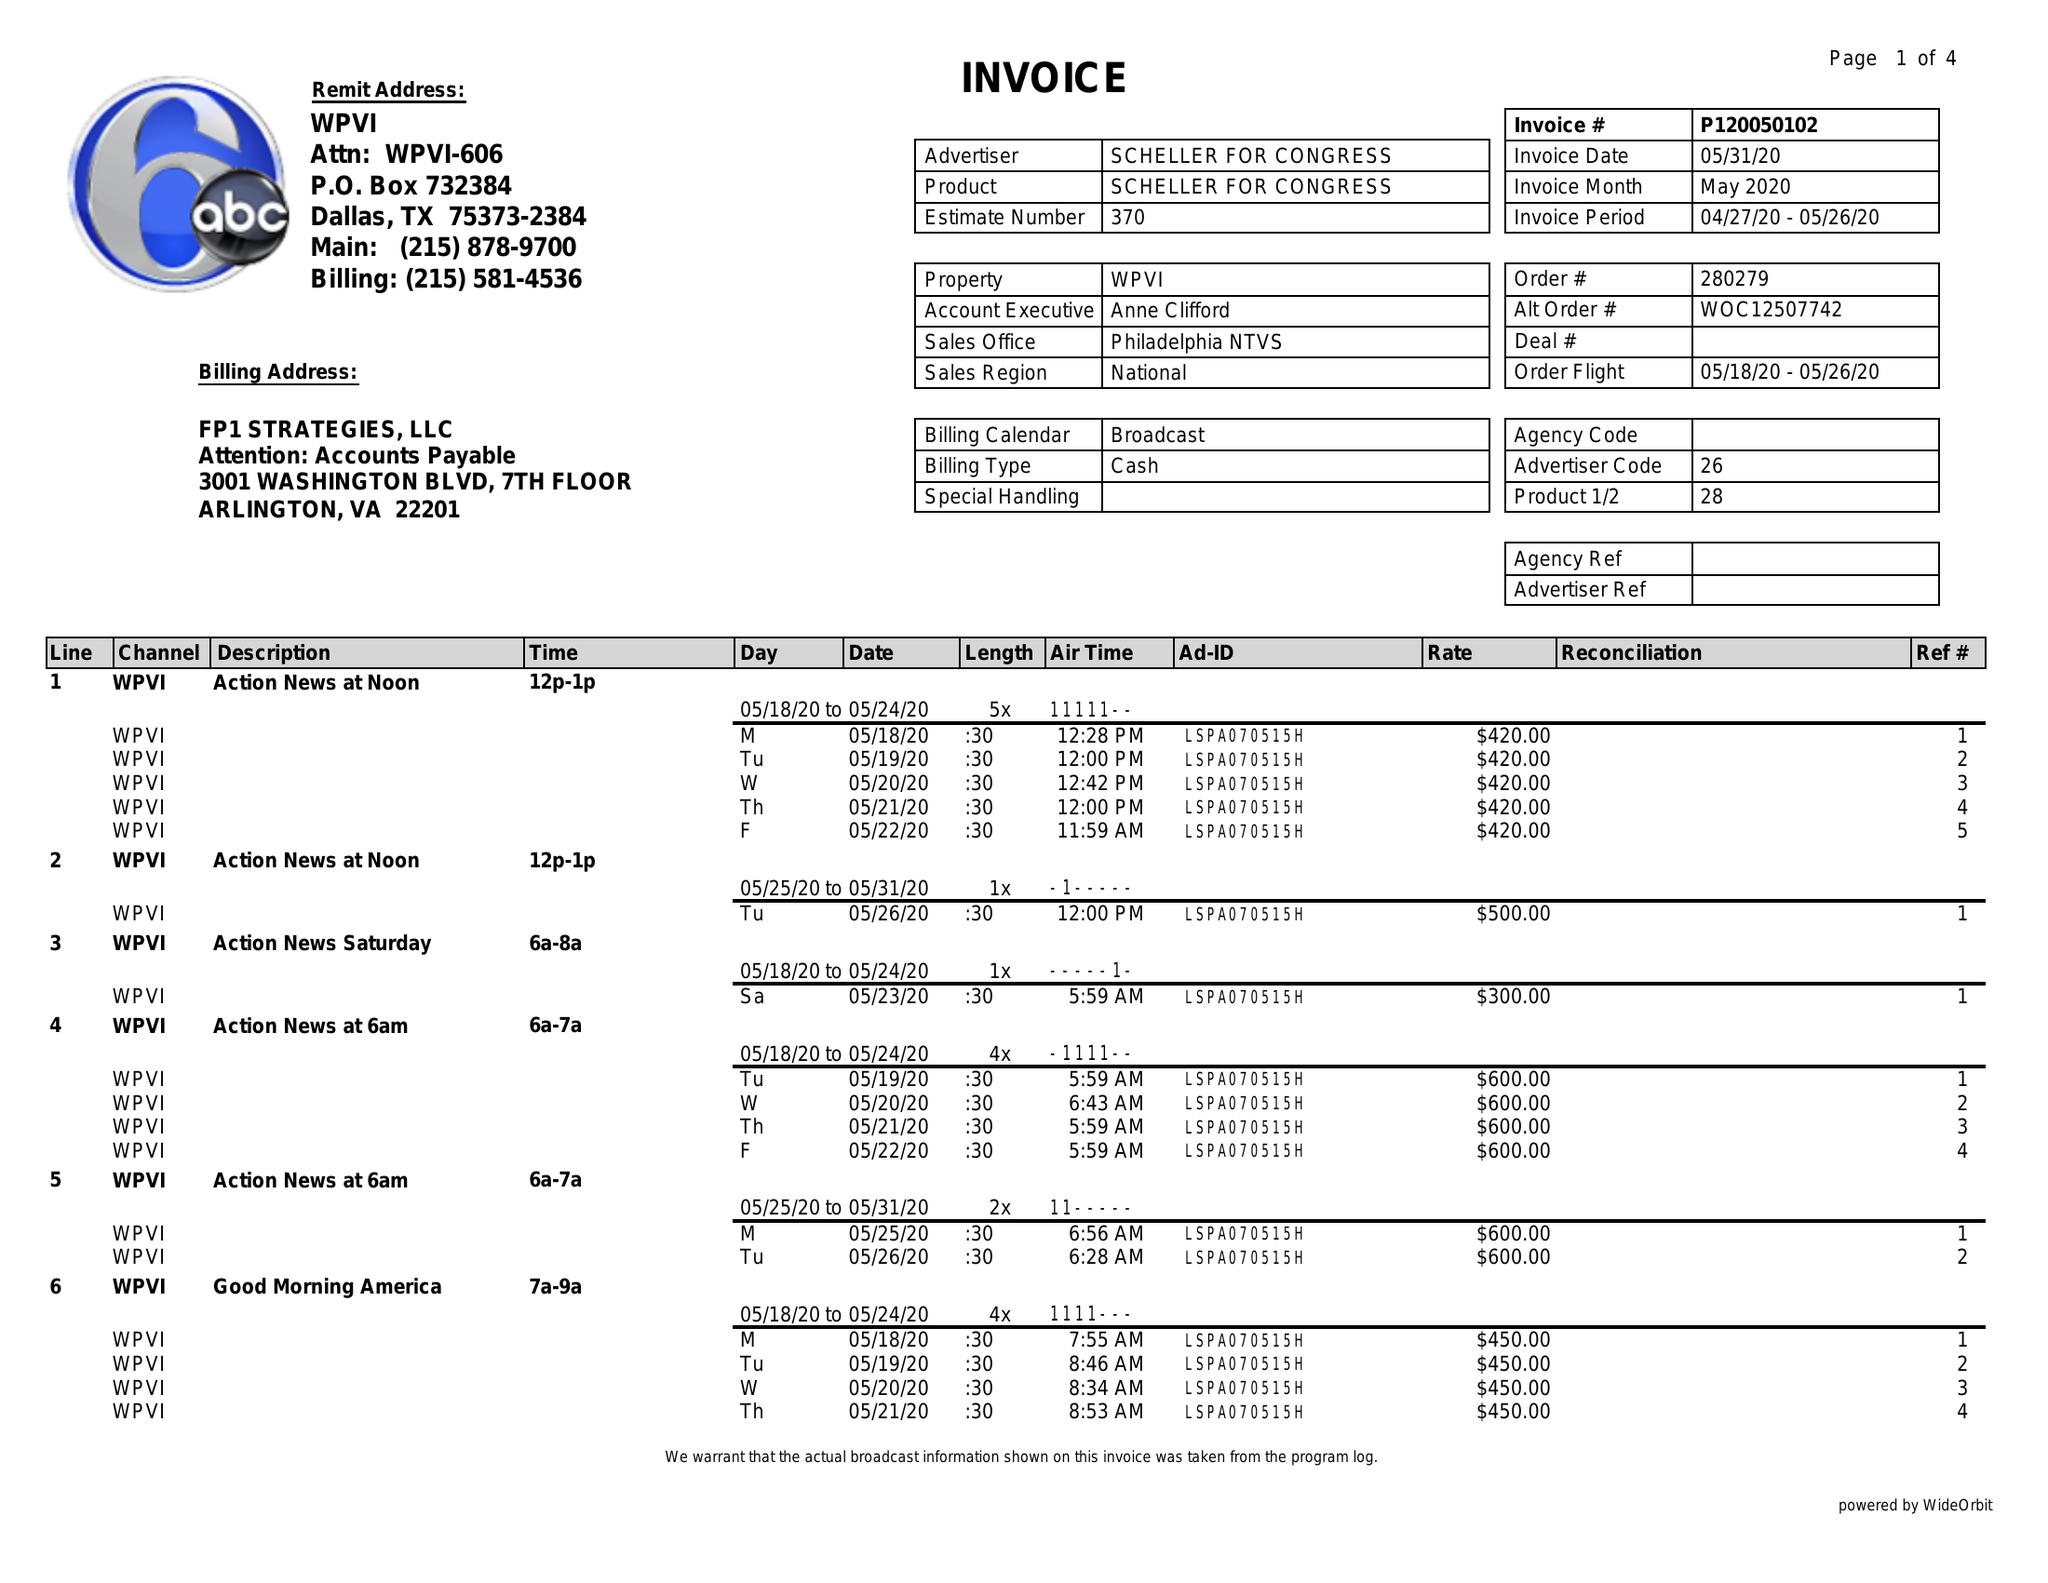What is the value for the advertiser?
Answer the question using a single word or phrase. SCHELLER FOR CONGRESS 